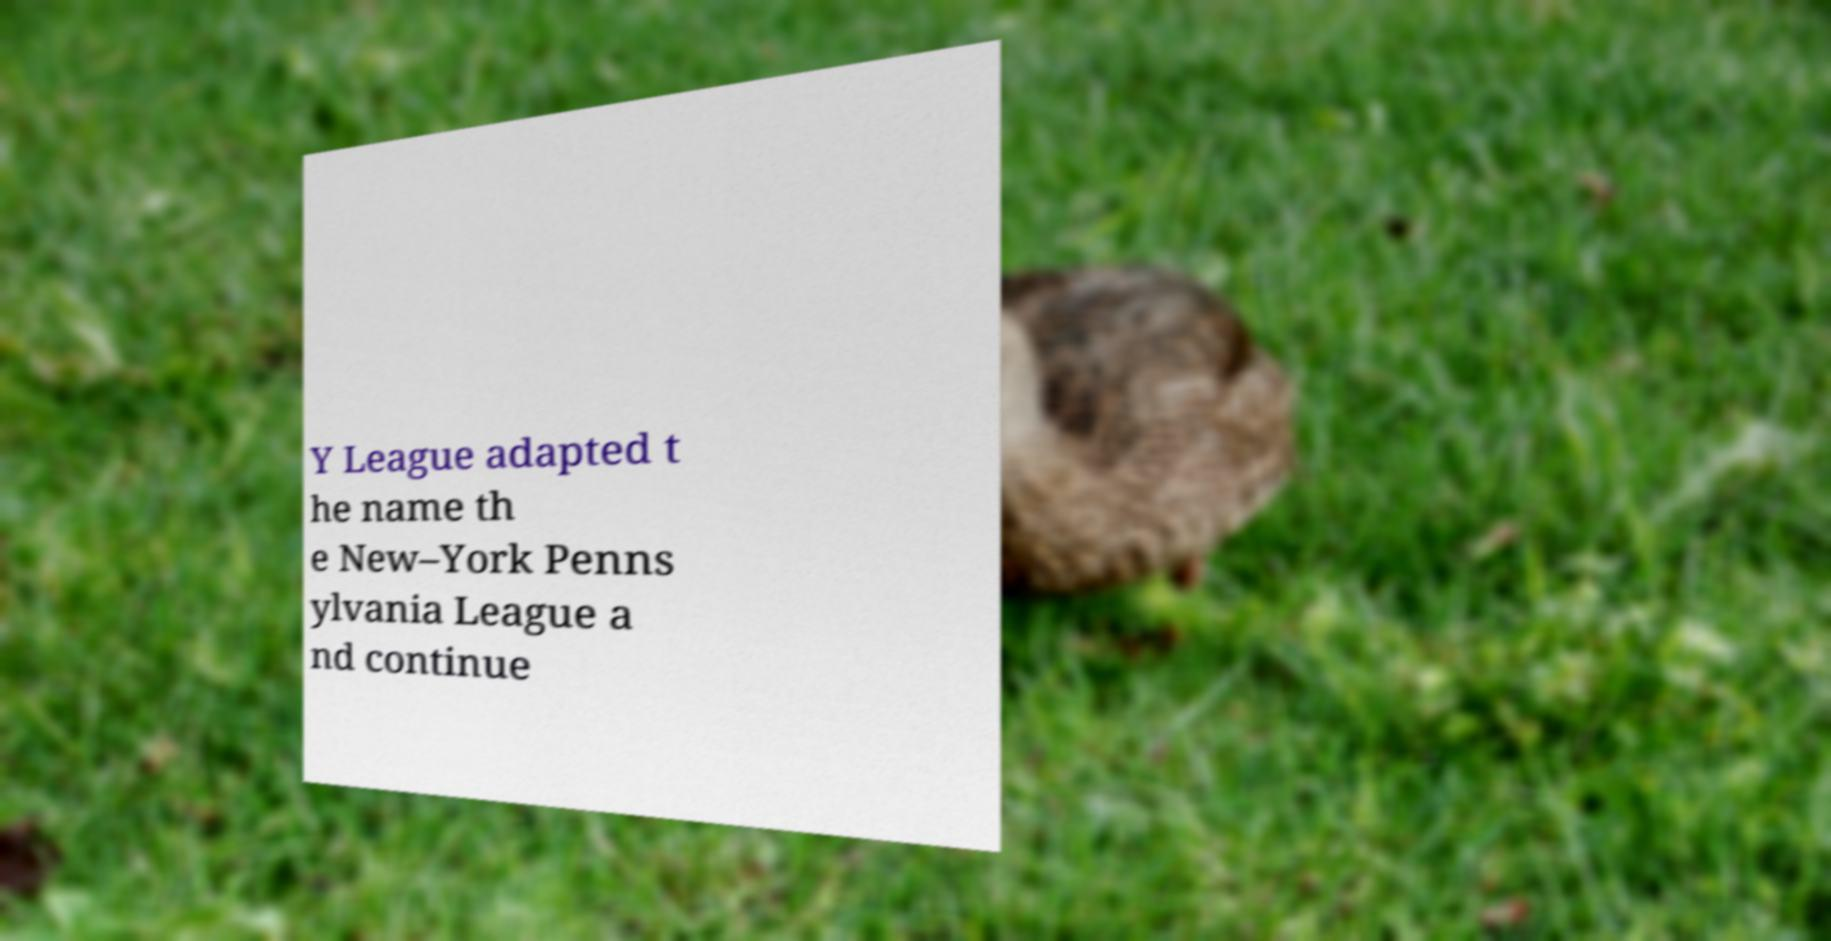What messages or text are displayed in this image? I need them in a readable, typed format. Y League adapted t he name th e New–York Penns ylvania League a nd continue 